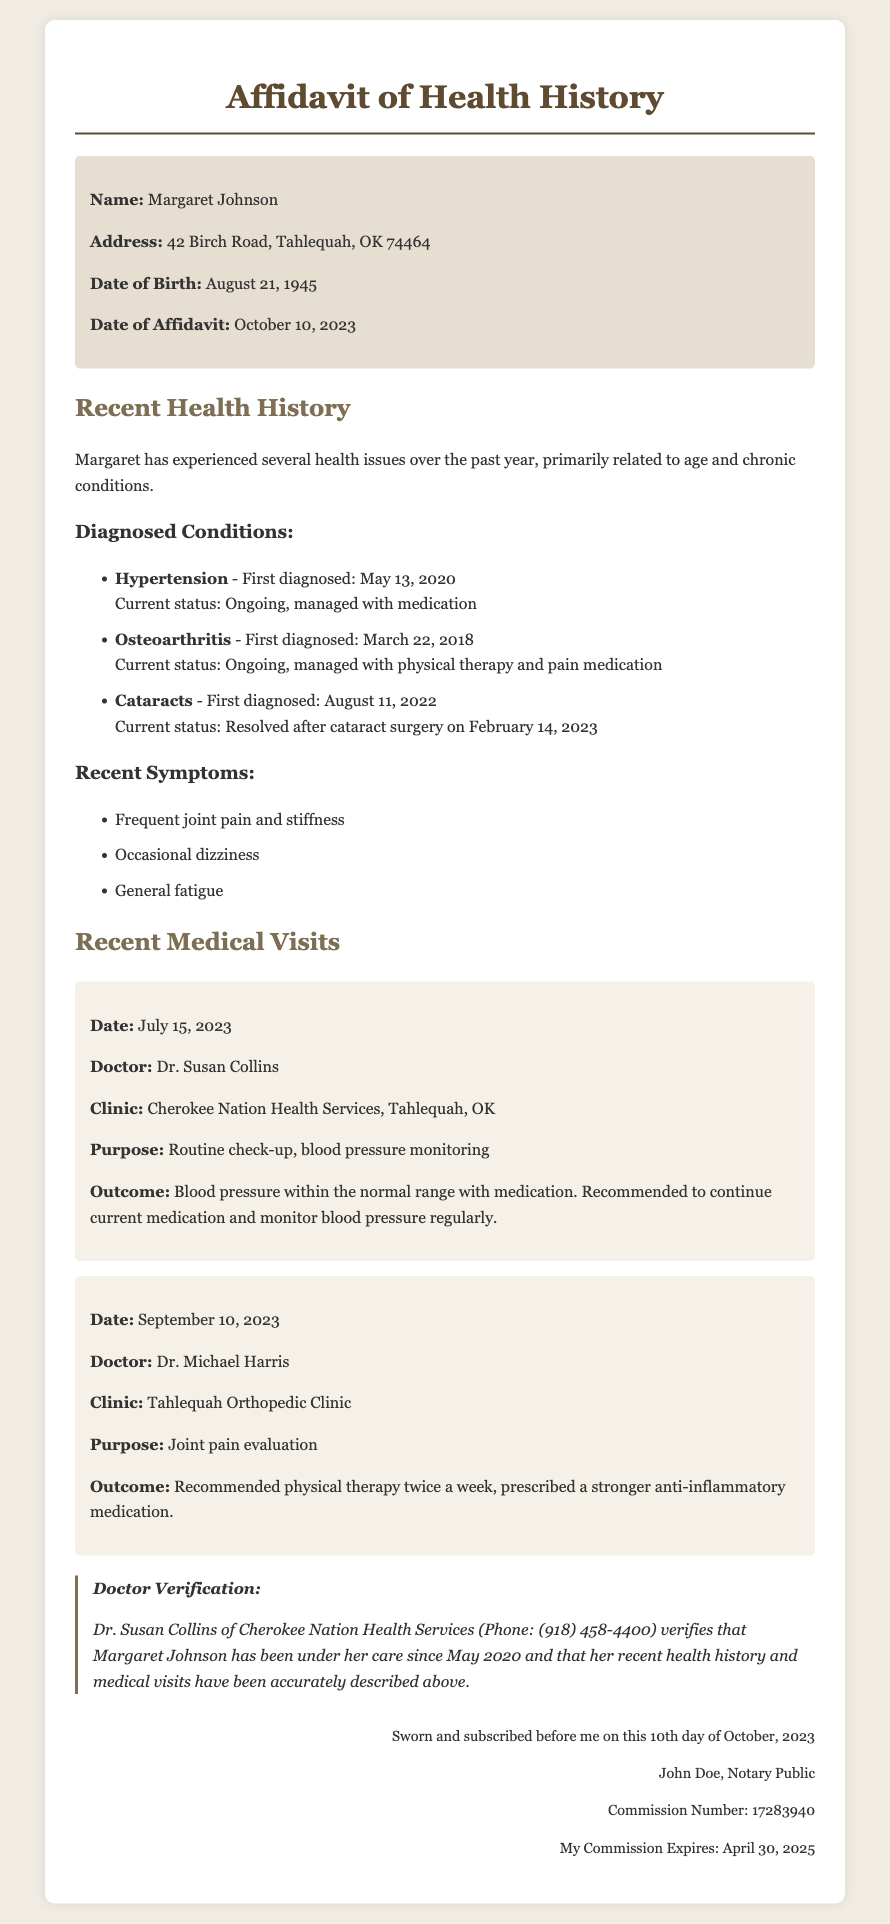What is the name of the person the affidavit is about? The affidavit discusses the health history of an individual named Margaret Johnson.
Answer: Margaret Johnson What is Margaret's date of birth? The document clearly states that Margaret was born on August 21, 1945.
Answer: August 21, 1945 What condition was diagnosed first? Among the listed diagnosed conditions, Hypertension was first diagnosed on May 13, 2020.
Answer: Hypertension How many medications were prescribed after the visit on September 10, 2023? The outcome of the visit specifies that a stronger anti-inflammatory medication was prescribed.
Answer: One What is the purpose of the visit on July 15, 2023? The document outlines that the purpose of the visit was for a routine check-up and blood pressure monitoring.
Answer: Routine check-up, blood pressure monitoring Who verified Margaret's health history in the affidavit? The verification section indicates that Dr. Susan Collins verified Margaret's health history.
Answer: Dr. Susan Collins When was the affidavit sworn? The notary section states that the affidavit was sworn on October 10, 2023.
Answer: October 10, 2023 How long is Dr. Collins' commission valid until? The notary section reveals that the commission for John Doe, Notary Public, expires on April 30, 2025.
Answer: April 30, 2025 What clinic did Margaret visit for her joint pain evaluation? The document specifies that Margaret visited Tahlequah Orthopedic Clinic for her joint pain evaluation.
Answer: Tahlequah Orthopedic Clinic 